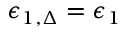<formula> <loc_0><loc_0><loc_500><loc_500>\epsilon _ { 1 , \Delta } = \epsilon _ { 1 }</formula> 